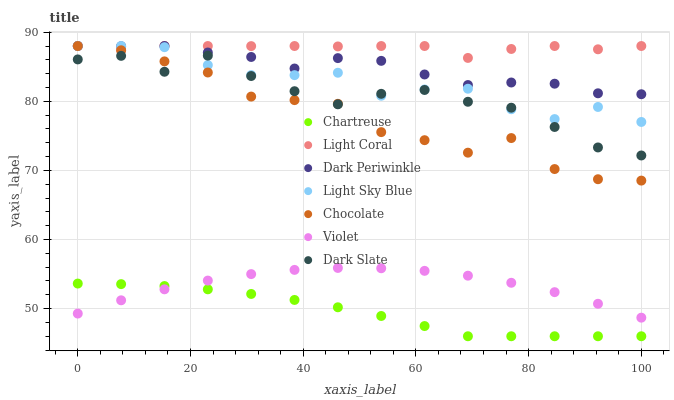Does Chartreuse have the minimum area under the curve?
Answer yes or no. Yes. Does Light Coral have the maximum area under the curve?
Answer yes or no. Yes. Does Dark Slate have the minimum area under the curve?
Answer yes or no. No. Does Dark Slate have the maximum area under the curve?
Answer yes or no. No. Is Chartreuse the smoothest?
Answer yes or no. Yes. Is Chocolate the roughest?
Answer yes or no. Yes. Is Light Coral the smoothest?
Answer yes or no. No. Is Light Coral the roughest?
Answer yes or no. No. Does Chartreuse have the lowest value?
Answer yes or no. Yes. Does Dark Slate have the lowest value?
Answer yes or no. No. Does Dark Periwinkle have the highest value?
Answer yes or no. Yes. Does Dark Slate have the highest value?
Answer yes or no. No. Is Violet less than Dark Slate?
Answer yes or no. Yes. Is Chocolate greater than Violet?
Answer yes or no. Yes. Does Violet intersect Chartreuse?
Answer yes or no. Yes. Is Violet less than Chartreuse?
Answer yes or no. No. Is Violet greater than Chartreuse?
Answer yes or no. No. Does Violet intersect Dark Slate?
Answer yes or no. No. 